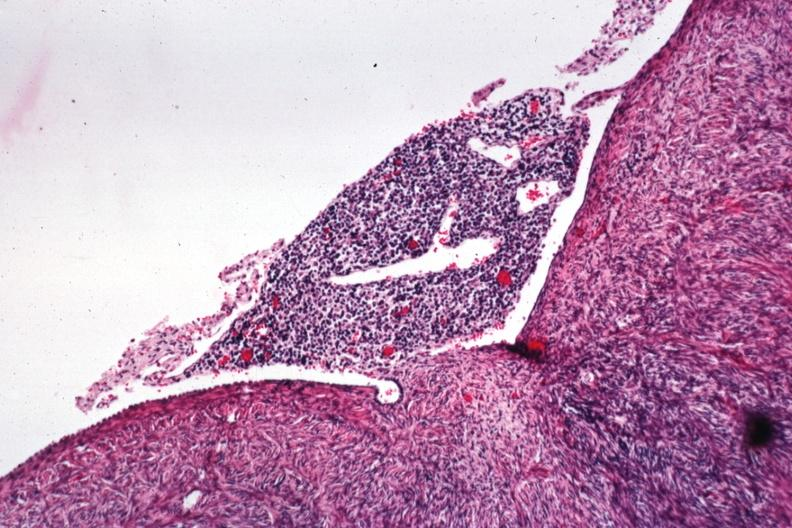does this image show lymphocytic infiltrate on peritoneal surface?
Answer the question using a single word or phrase. Yes 